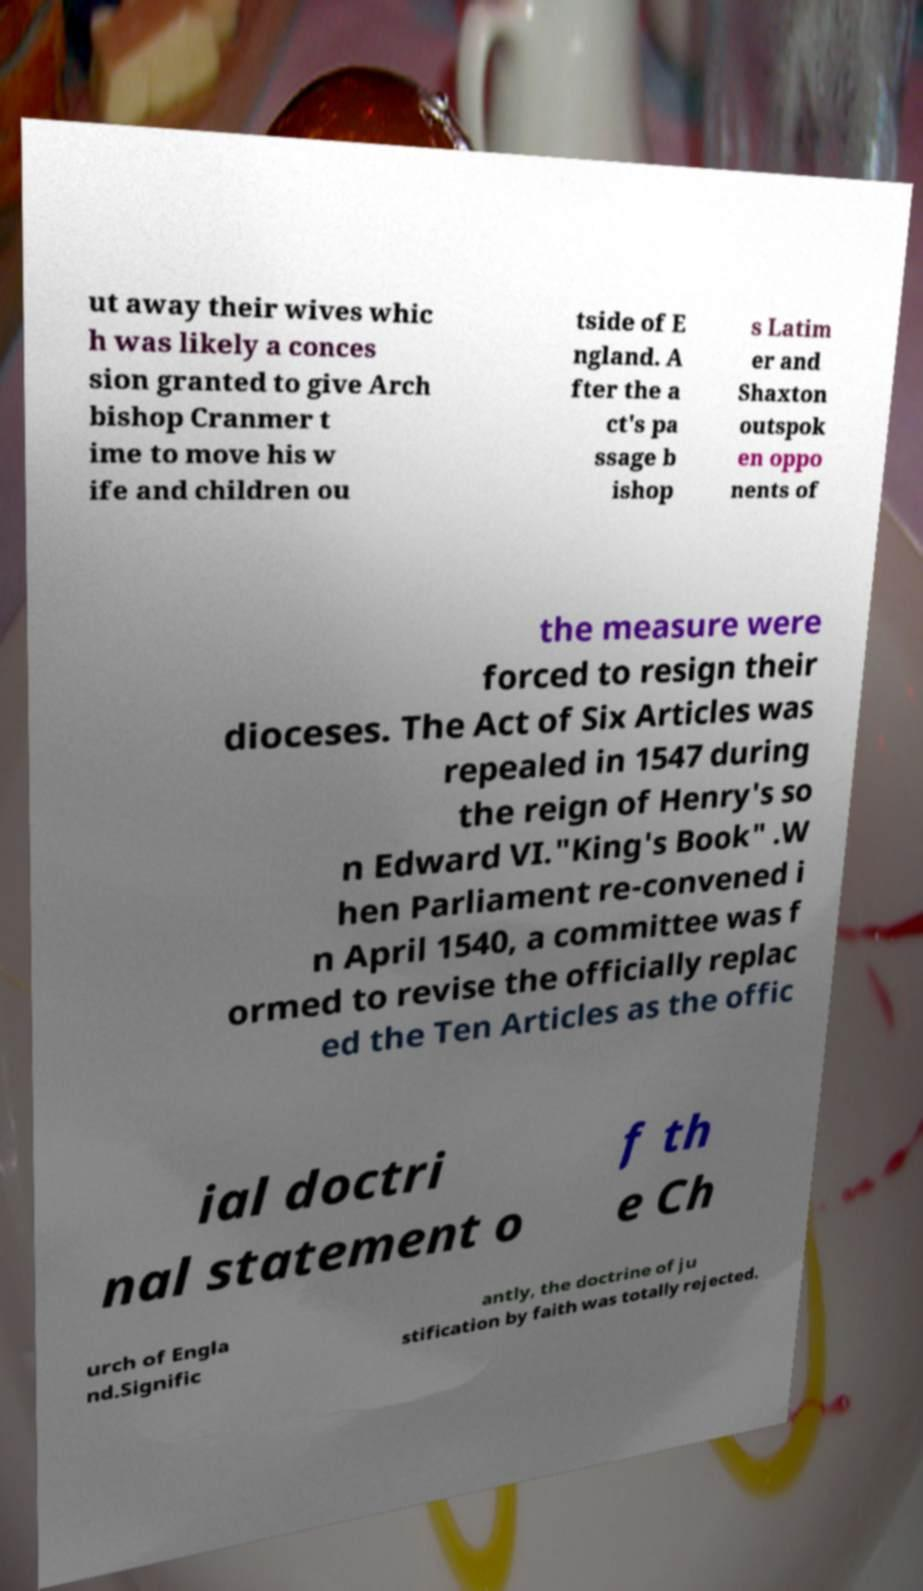I need the written content from this picture converted into text. Can you do that? ut away their wives whic h was likely a conces sion granted to give Arch bishop Cranmer t ime to move his w ife and children ou tside of E ngland. A fter the a ct's pa ssage b ishop s Latim er and Shaxton outspok en oppo nents of the measure were forced to resign their dioceses. The Act of Six Articles was repealed in 1547 during the reign of Henry's so n Edward VI."King's Book" .W hen Parliament re-convened i n April 1540, a committee was f ormed to revise the officially replac ed the Ten Articles as the offic ial doctri nal statement o f th e Ch urch of Engla nd.Signific antly, the doctrine of ju stification by faith was totally rejected. 